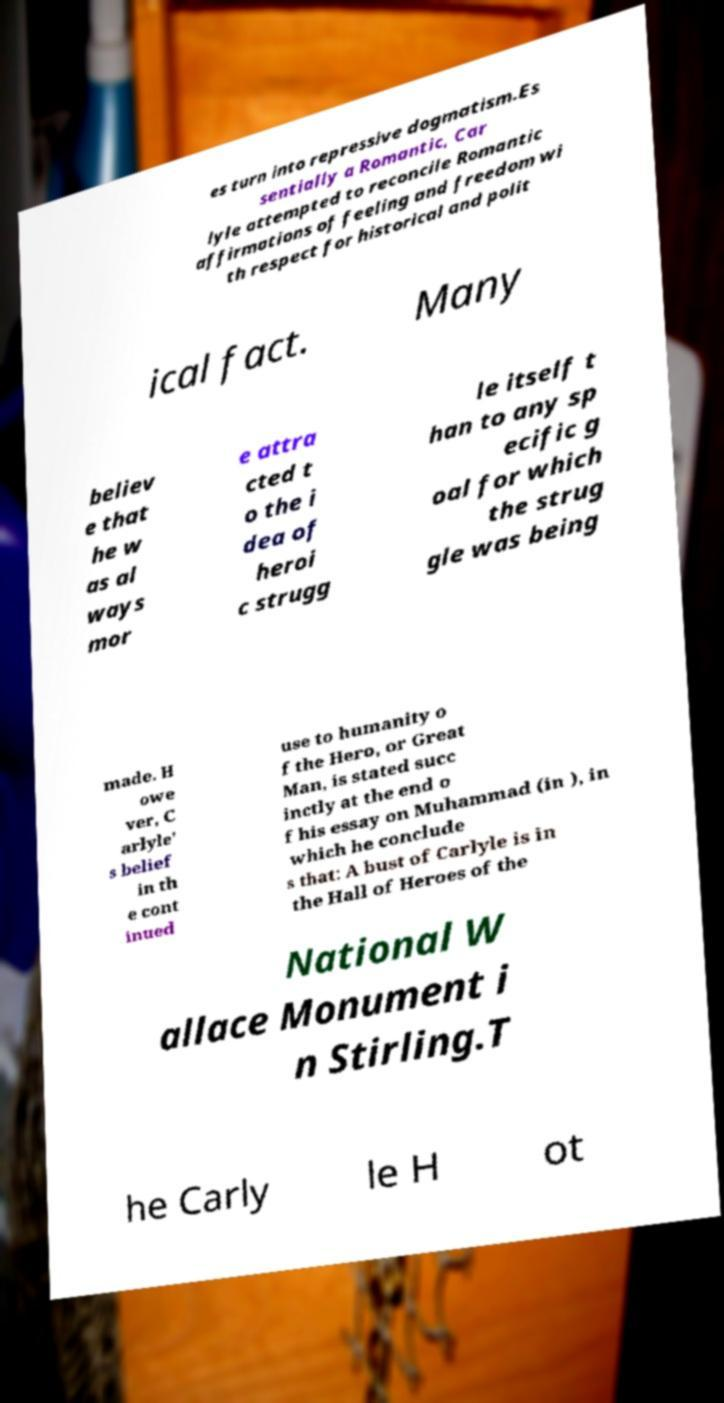Can you accurately transcribe the text from the provided image for me? es turn into repressive dogmatism.Es sentially a Romantic, Car lyle attempted to reconcile Romantic affirmations of feeling and freedom wi th respect for historical and polit ical fact. Many believ e that he w as al ways mor e attra cted t o the i dea of heroi c strugg le itself t han to any sp ecific g oal for which the strug gle was being made. H owe ver, C arlyle' s belief in th e cont inued use to humanity o f the Hero, or Great Man, is stated succ inctly at the end o f his essay on Muhammad (in ), in which he conclude s that: A bust of Carlyle is in the Hall of Heroes of the National W allace Monument i n Stirling.T he Carly le H ot 